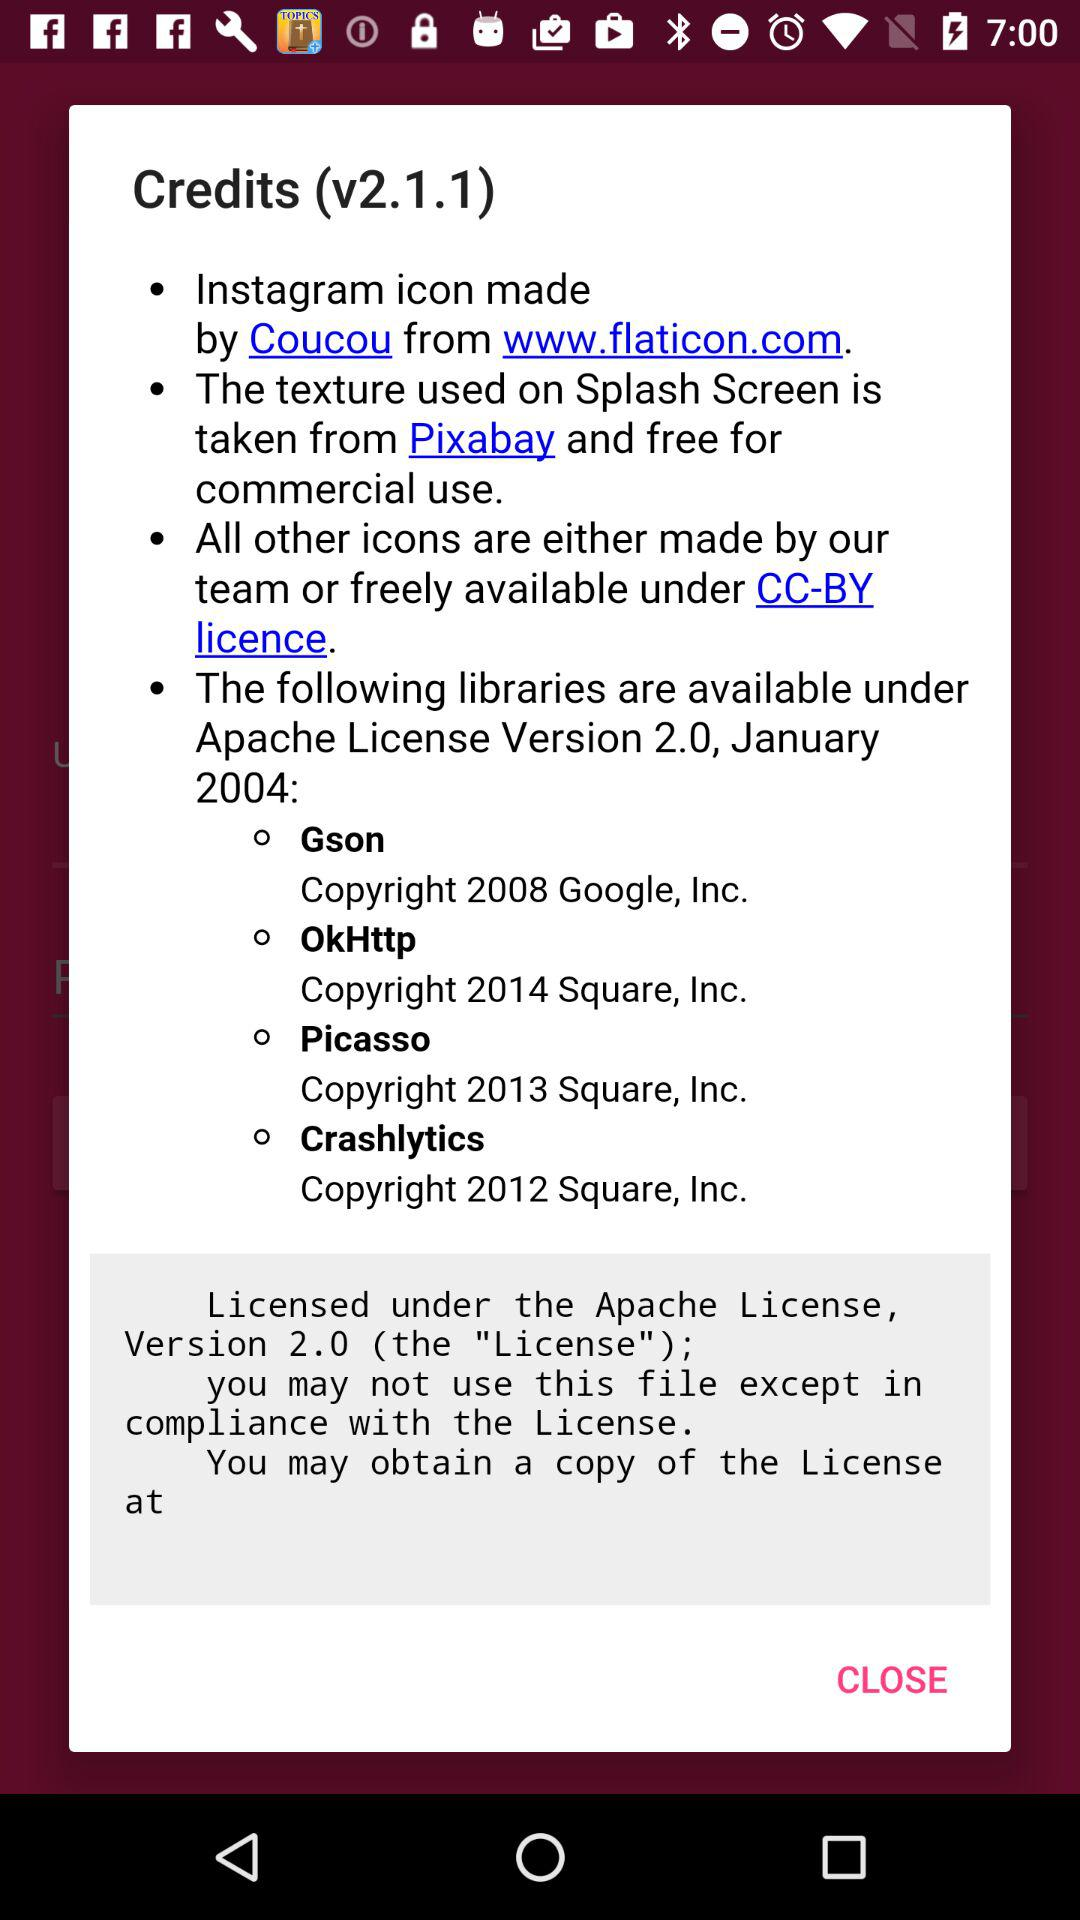From where is the texture used on the splash screen taken? The texture used on the splash screen is taken from "Pixabay". 